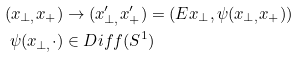<formula> <loc_0><loc_0><loc_500><loc_500>( x _ { \perp , } x _ { + } ) & \rightarrow ( x _ { \perp , } ^ { \prime } x _ { + } ^ { \prime } ) = ( E x _ { \perp } , \psi ( x _ { \perp , } x _ { + } ) ) \\ \psi ( x _ { \perp , } \cdot ) & \in D i f f ( S ^ { 1 } )</formula> 